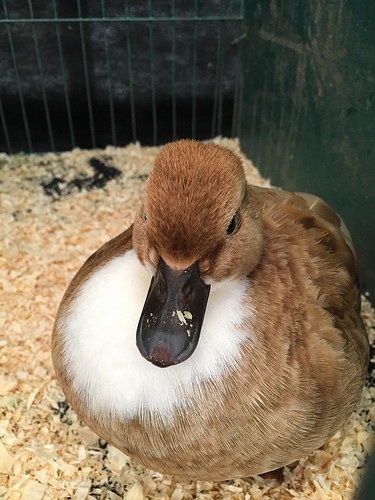<image>
Is the duck behind the cage? No. The duck is not behind the cage. From this viewpoint, the duck appears to be positioned elsewhere in the scene. 